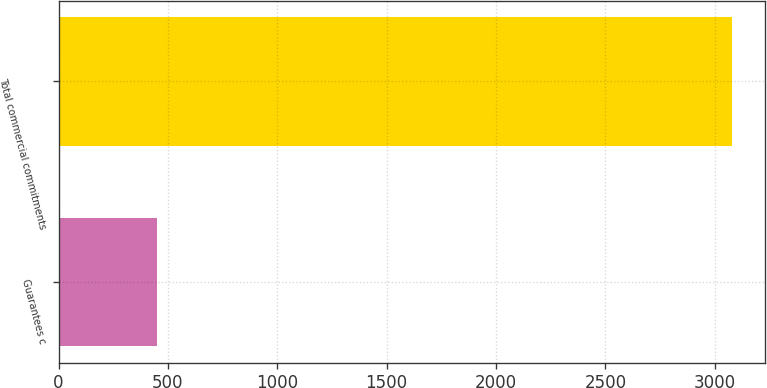Convert chart. <chart><loc_0><loc_0><loc_500><loc_500><bar_chart><fcel>Guarantees c<fcel>Total commercial commitments<nl><fcel>449<fcel>3077<nl></chart> 